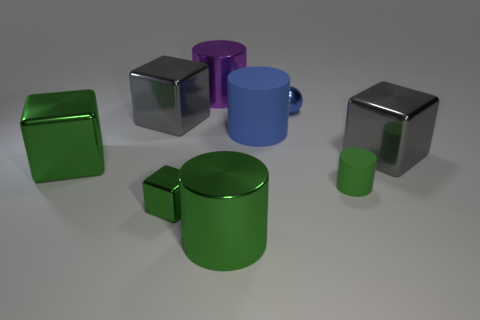What is the shape of the large blue rubber object?
Offer a very short reply. Cylinder. What is the size of the rubber thing that is the same color as the tiny metallic sphere?
Offer a terse response. Large. What is the color of the tiny thing that is the same material as the blue cylinder?
Provide a succinct answer. Green. Do the large purple cylinder and the large gray thing that is right of the large green cylinder have the same material?
Your response must be concise. Yes. What color is the large rubber cylinder?
Ensure brevity in your answer.  Blue. There is a green thing that is the same material as the big blue cylinder; what size is it?
Your answer should be compact. Small. How many large purple objects are in front of the gray thing that is left of the big green metallic thing that is in front of the large green block?
Provide a short and direct response. 0. Is the color of the large rubber cylinder the same as the sphere that is behind the tiny green shiny thing?
Provide a short and direct response. Yes. What is the shape of the tiny thing that is the same color as the small rubber cylinder?
Make the answer very short. Cube. What is the material of the big green object that is on the left side of the large green shiny cylinder that is on the right side of the gray metal object that is to the left of the tiny metallic ball?
Ensure brevity in your answer.  Metal. 